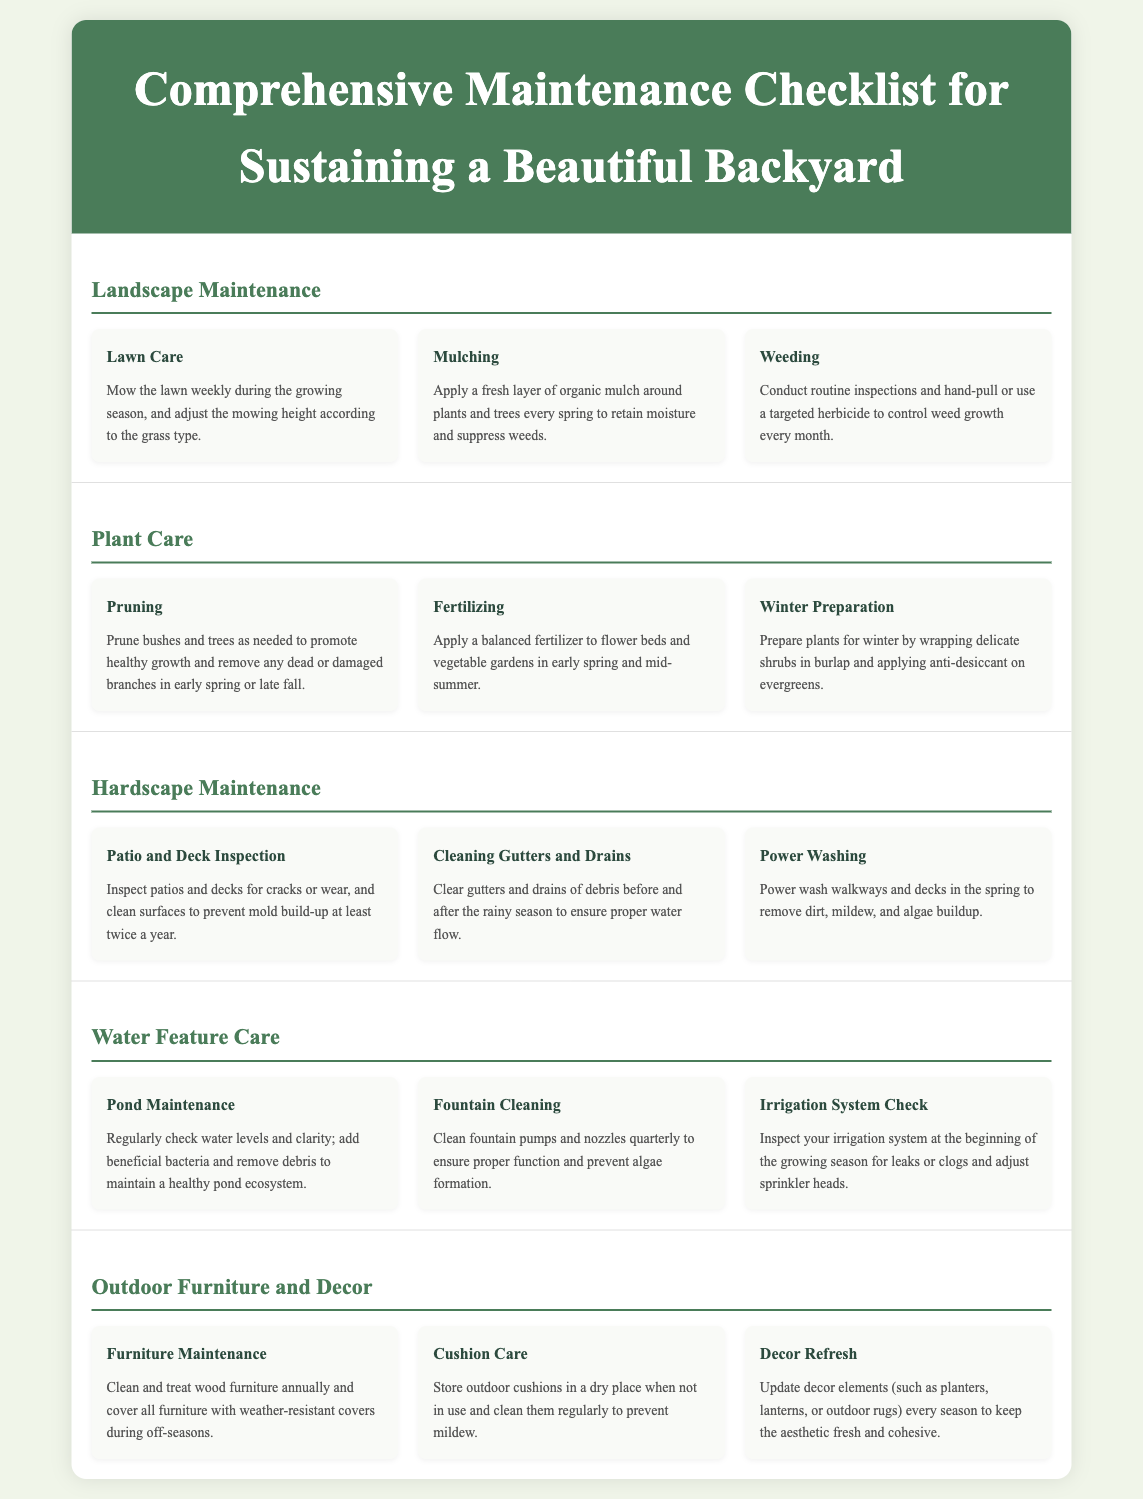what is the title of the document? The title of the document is located in the header section, clearly stating its purpose.
Answer: Comprehensive Maintenance Checklist for Sustaining a Beautiful Backyard how often should the lawn be mowed? The document specifies the frequency of lawn mowing during the growing season.
Answer: weekly what task involves applying mulch? The task related to mulch application is mentioned in the landscape maintenance section.
Answer: Mulching when should pruning be done? The document indicates the specific times for pruning bushes and trees for optimal growth.
Answer: early spring or late fall how frequently should fountain pumps be cleaned? The document provides a schedule for cleaning fountain pumps to maintain functionality.
Answer: quarterly what is the purpose of applying a balanced fertilizer? The document outlines the reason for fertilization in plant care, ensuring healthy growth.
Answer: to promote healthy growth how should outdoor cushions be stored? The document gives advice on the proper storage method for outdoor cushions to prevent mildew.
Answer: in a dry place what is one essential check to perform on the irrigation system? The document highlights an important inspection to maintain the irrigation system's effectiveness.
Answer: leaks or clogs what is the recommended action for wooden furniture annually? The document outlines a specific maintenance task for wooden furniture every year.
Answer: clean and treat 